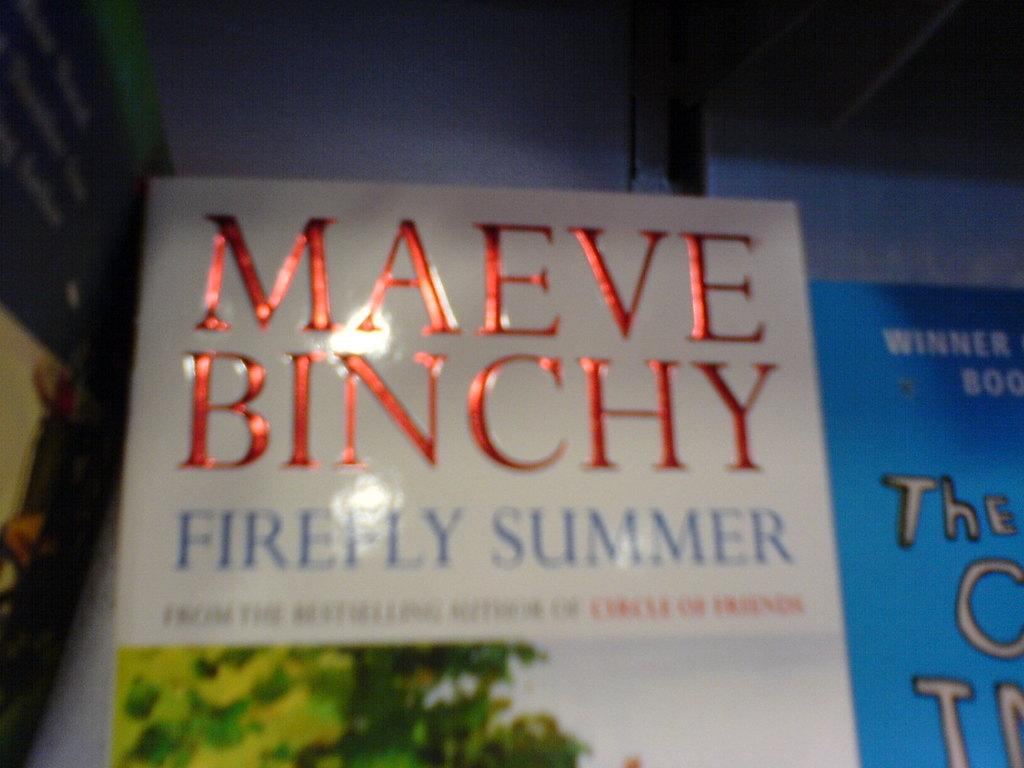<image>
Give a short and clear explanation of the subsequent image. a book titled 'firefly summer' by maeve binchy 